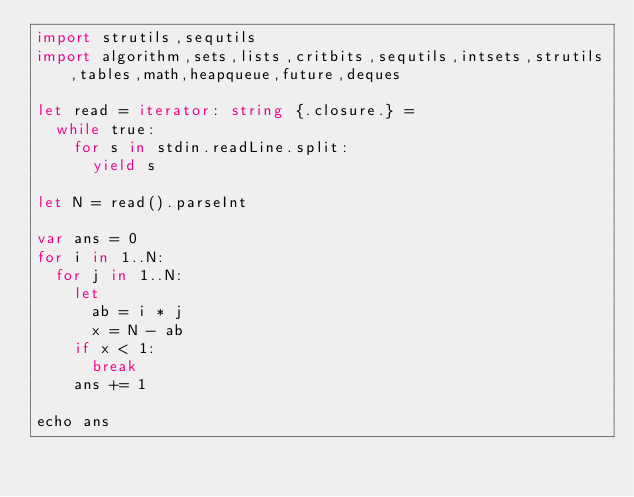<code> <loc_0><loc_0><loc_500><loc_500><_Nim_>import strutils,sequtils
import algorithm,sets,lists,critbits,sequtils,intsets,strutils,tables,math,heapqueue,future,deques

let read = iterator: string {.closure.} =
  while true:
    for s in stdin.readLine.split:
      yield s

let N = read().parseInt

var ans = 0
for i in 1..N:
  for j in 1..N:
    let
      ab = i * j
      x = N - ab
    if x < 1:
      break
    ans += 1

echo ans
</code> 